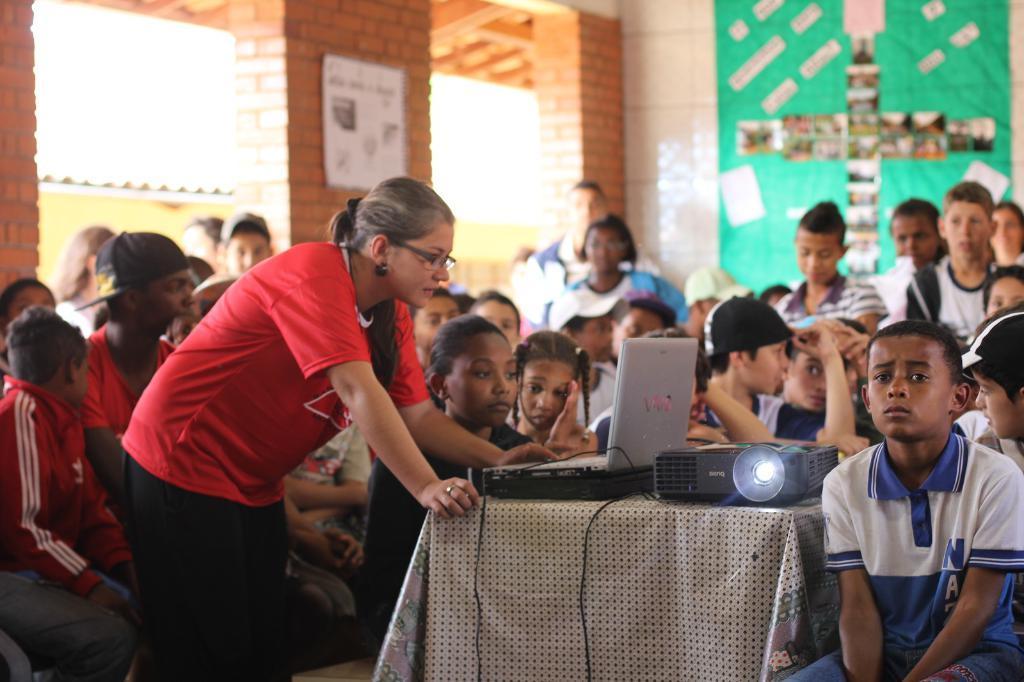How would you summarize this image in a sentence or two? On the background of the picture we can see a wall with bricks. This is a green colour sheet with photos. Here we can see all the persons sitting and standing. This is a table and we can see a cloth on it and also a projector and a laptop. Here we can see one woman standing and wearing spectacles and looking into the laptop. 